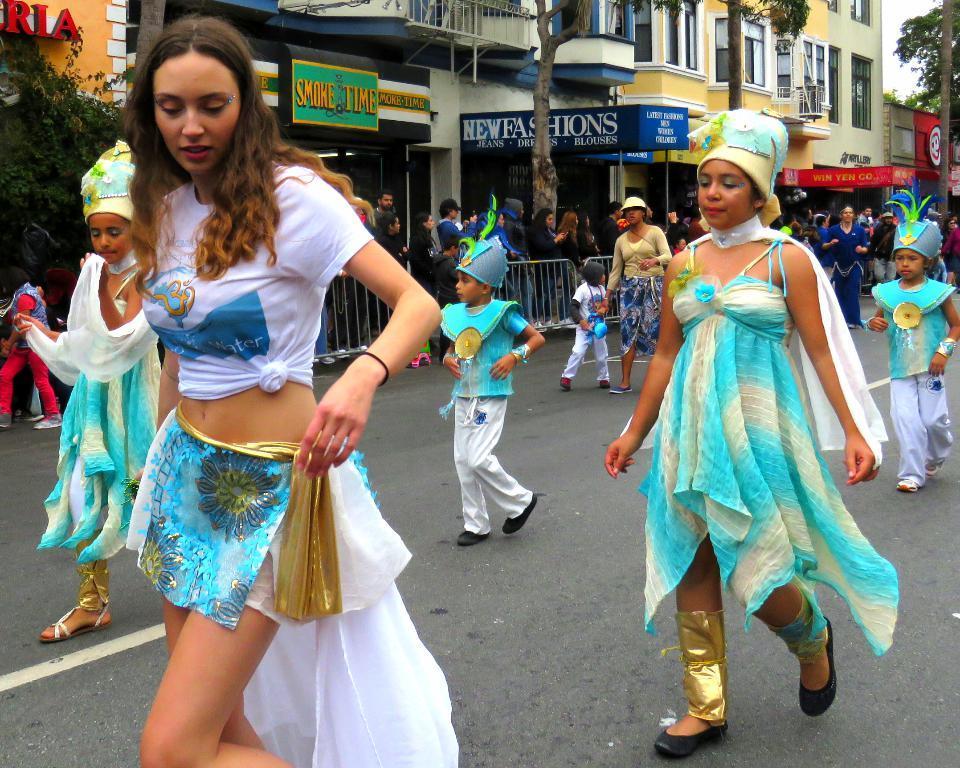Describe this image in one or two sentences. In this picture, we can see a few people, and a few are in a costume, we can see the road, buildings with windows, doors, stores, posters, poles, trees, plants, fencing, and the sky. 